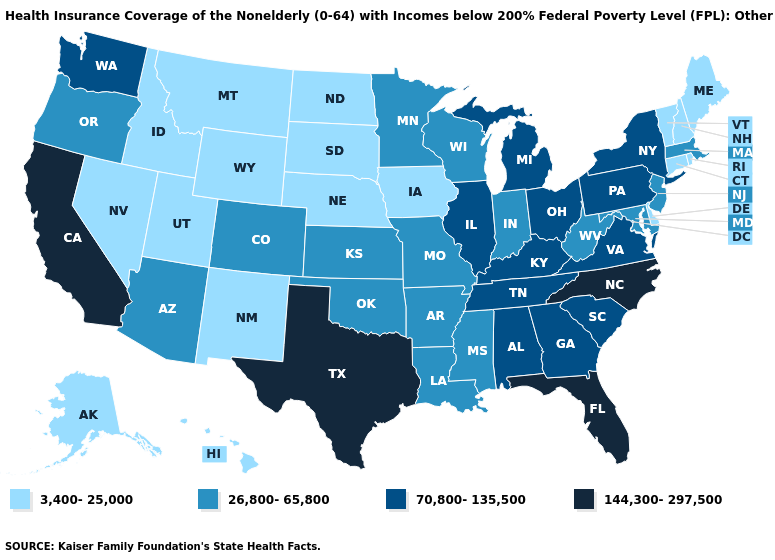Does South Dakota have the highest value in the USA?
Give a very brief answer. No. Name the states that have a value in the range 144,300-297,500?
Give a very brief answer. California, Florida, North Carolina, Texas. Does Virginia have the same value as Delaware?
Answer briefly. No. Name the states that have a value in the range 144,300-297,500?
Write a very short answer. California, Florida, North Carolina, Texas. Does North Carolina have the highest value in the USA?
Give a very brief answer. Yes. Which states have the highest value in the USA?
Short answer required. California, Florida, North Carolina, Texas. Among the states that border Indiana , which have the lowest value?
Concise answer only. Illinois, Kentucky, Michigan, Ohio. Name the states that have a value in the range 70,800-135,500?
Answer briefly. Alabama, Georgia, Illinois, Kentucky, Michigan, New York, Ohio, Pennsylvania, South Carolina, Tennessee, Virginia, Washington. Name the states that have a value in the range 3,400-25,000?
Give a very brief answer. Alaska, Connecticut, Delaware, Hawaii, Idaho, Iowa, Maine, Montana, Nebraska, Nevada, New Hampshire, New Mexico, North Dakota, Rhode Island, South Dakota, Utah, Vermont, Wyoming. What is the lowest value in states that border Wyoming?
Keep it brief. 3,400-25,000. Which states have the lowest value in the MidWest?
Give a very brief answer. Iowa, Nebraska, North Dakota, South Dakota. Does Indiana have the highest value in the MidWest?
Answer briefly. No. What is the value of Nebraska?
Concise answer only. 3,400-25,000. What is the highest value in the MidWest ?
Answer briefly. 70,800-135,500. 